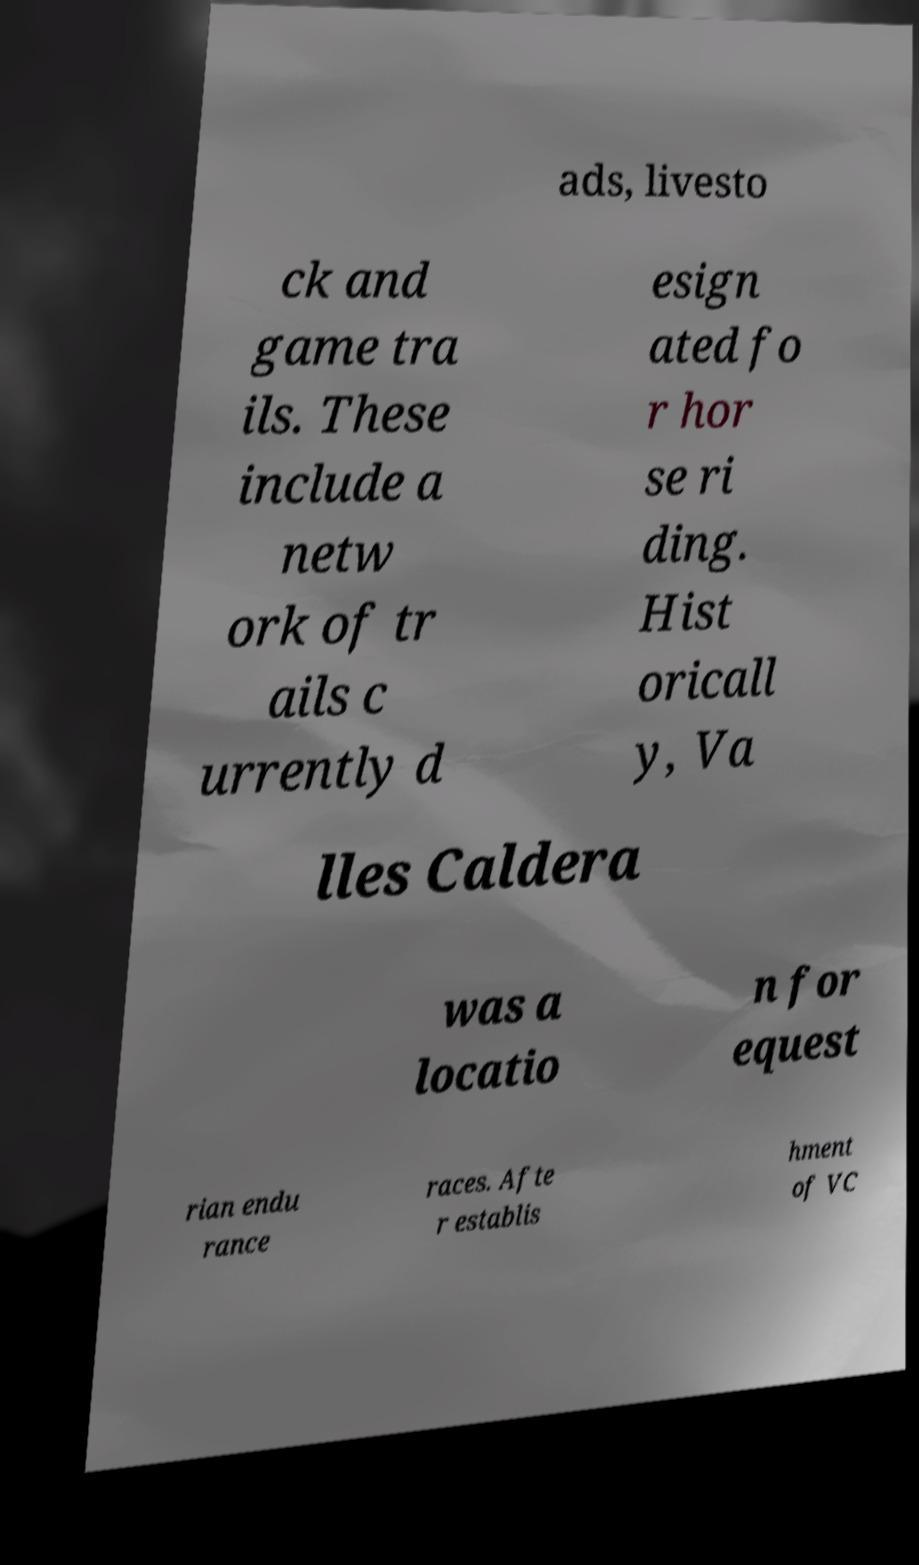Could you extract and type out the text from this image? ads, livesto ck and game tra ils. These include a netw ork of tr ails c urrently d esign ated fo r hor se ri ding. Hist oricall y, Va lles Caldera was a locatio n for equest rian endu rance races. Afte r establis hment of VC 